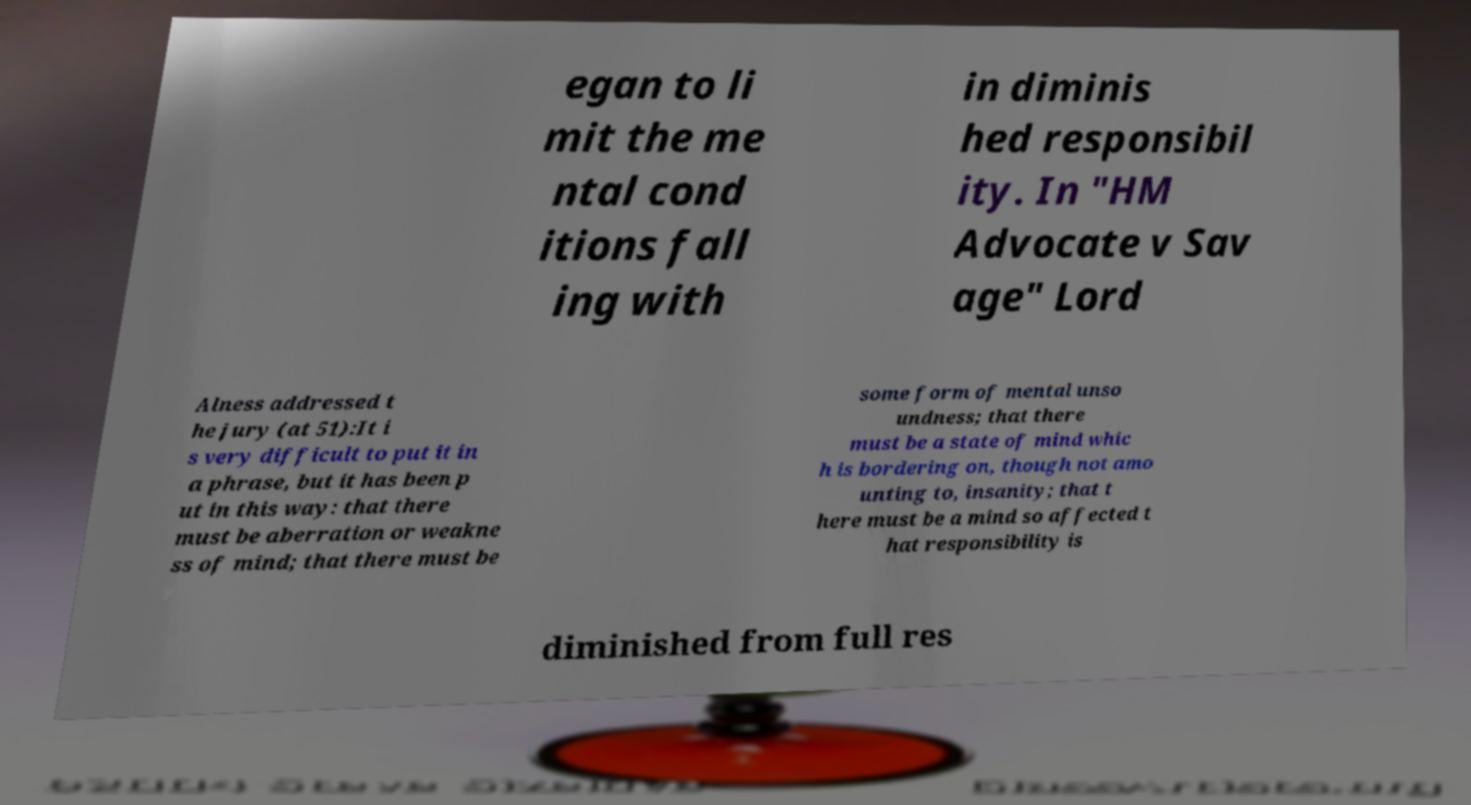Could you extract and type out the text from this image? egan to li mit the me ntal cond itions fall ing with in diminis hed responsibil ity. In "HM Advocate v Sav age" Lord Alness addressed t he jury (at 51):It i s very difficult to put it in a phrase, but it has been p ut in this way: that there must be aberration or weakne ss of mind; that there must be some form of mental unso undness; that there must be a state of mind whic h is bordering on, though not amo unting to, insanity; that t here must be a mind so affected t hat responsibility is diminished from full res 